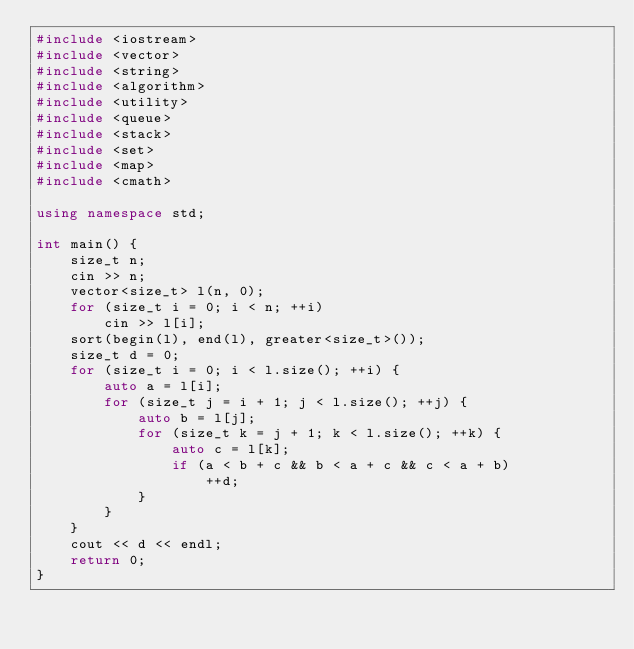Convert code to text. <code><loc_0><loc_0><loc_500><loc_500><_C++_>#include <iostream>
#include <vector>
#include <string>
#include <algorithm>
#include <utility>
#include <queue>
#include <stack>
#include <set>
#include <map>
#include <cmath>

using namespace std;

int main() {
    size_t n;
    cin >> n;
    vector<size_t> l(n, 0);
    for (size_t i = 0; i < n; ++i)
        cin >> l[i];
    sort(begin(l), end(l), greater<size_t>());
    size_t d = 0;
    for (size_t i = 0; i < l.size(); ++i) {
        auto a = l[i];
        for (size_t j = i + 1; j < l.size(); ++j) {
            auto b = l[j];
            for (size_t k = j + 1; k < l.size(); ++k) {
                auto c = l[k];
                if (a < b + c && b < a + c && c < a + b)
                    ++d;
            }
        }
    }
    cout << d << endl;
    return 0;
}
</code> 